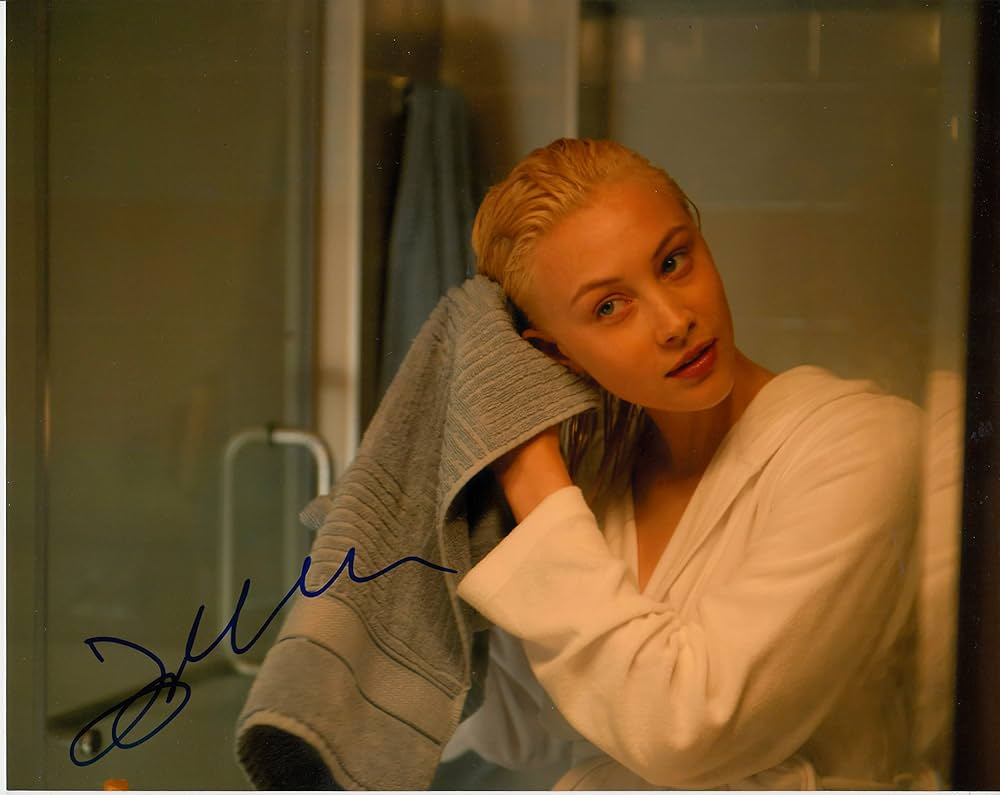Explain the visual content of the image in great detail. The image showcases a woman in a bathroom, appearing composed and directly engaging with the viewer. She is clad in a white robe that adds a sense of relaxed comfort to her demeanor. Her hair, visibly wet, is being dried with a grey towel, suggesting she may have just taken a bath or shower. The warm lighting enhances the serene atmosphere, complementing her calm, introspective expression. The setting, simple and uncluttered with visible details like a glass panel and reflections on the smooth surfaces, focuses attention on her and her subtle interaction with the viewer. 